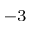Convert formula to latex. <formula><loc_0><loc_0><loc_500><loc_500>^ { - 3 }</formula> 